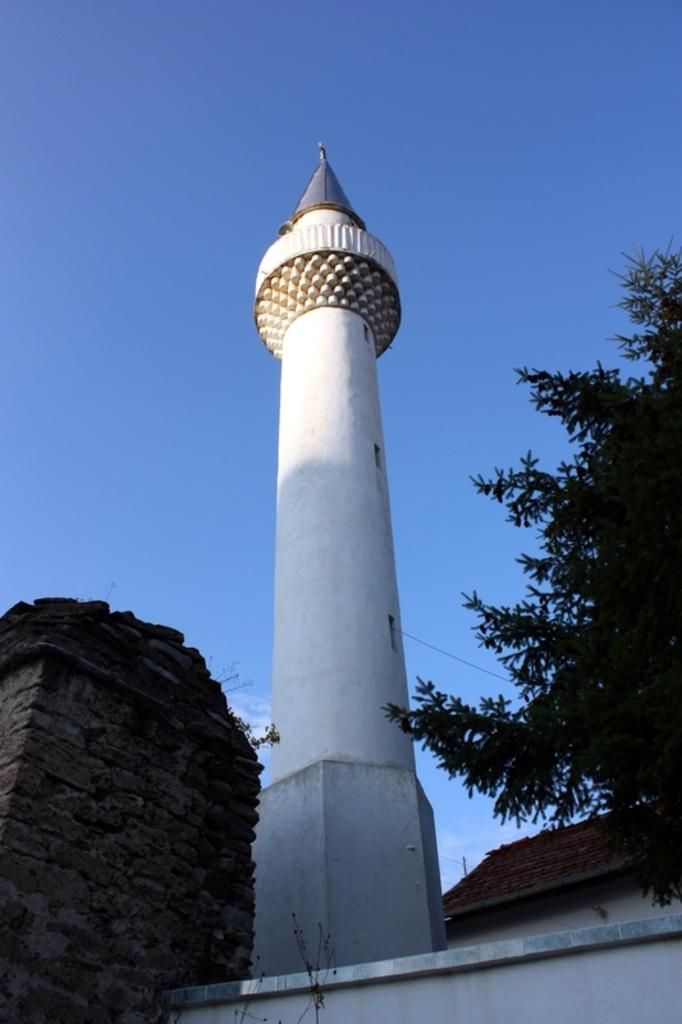What is the main structure in the image? There is a big tower in the image. What type of natural element can be seen in the image? There is a tree in the image. Are there any architectural features visible in the image? Yes, there are pillars in the image. What type of pets can be seen playing with a button in the image? There are no pets or buttons present in the image. Where is the lunchroom located in the image? There is no lunchroom present in the image. 